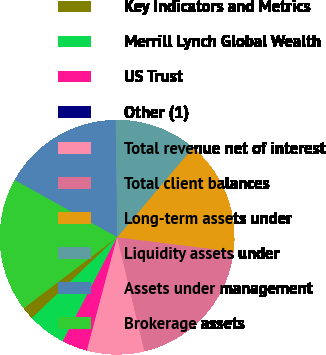Convert chart to OTSL. <chart><loc_0><loc_0><loc_500><loc_500><pie_chart><fcel>Key Indicators and Metrics<fcel>Merrill Lynch Global Wealth<fcel>US Trust<fcel>Other (1)<fcel>Total revenue net of interest<fcel>Total client balances<fcel>Long-term assets under<fcel>Liquidity assets under<fcel>Assets under management<fcel>Brokerage assets<nl><fcel>1.75%<fcel>5.26%<fcel>3.51%<fcel>0.0%<fcel>7.89%<fcel>19.3%<fcel>15.79%<fcel>11.4%<fcel>16.67%<fcel>18.42%<nl></chart> 